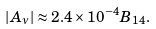Convert formula to latex. <formula><loc_0><loc_0><loc_500><loc_500>| A _ { \nu } | \approx 2 . 4 \times 1 0 ^ { - 4 } B _ { 1 4 } .</formula> 